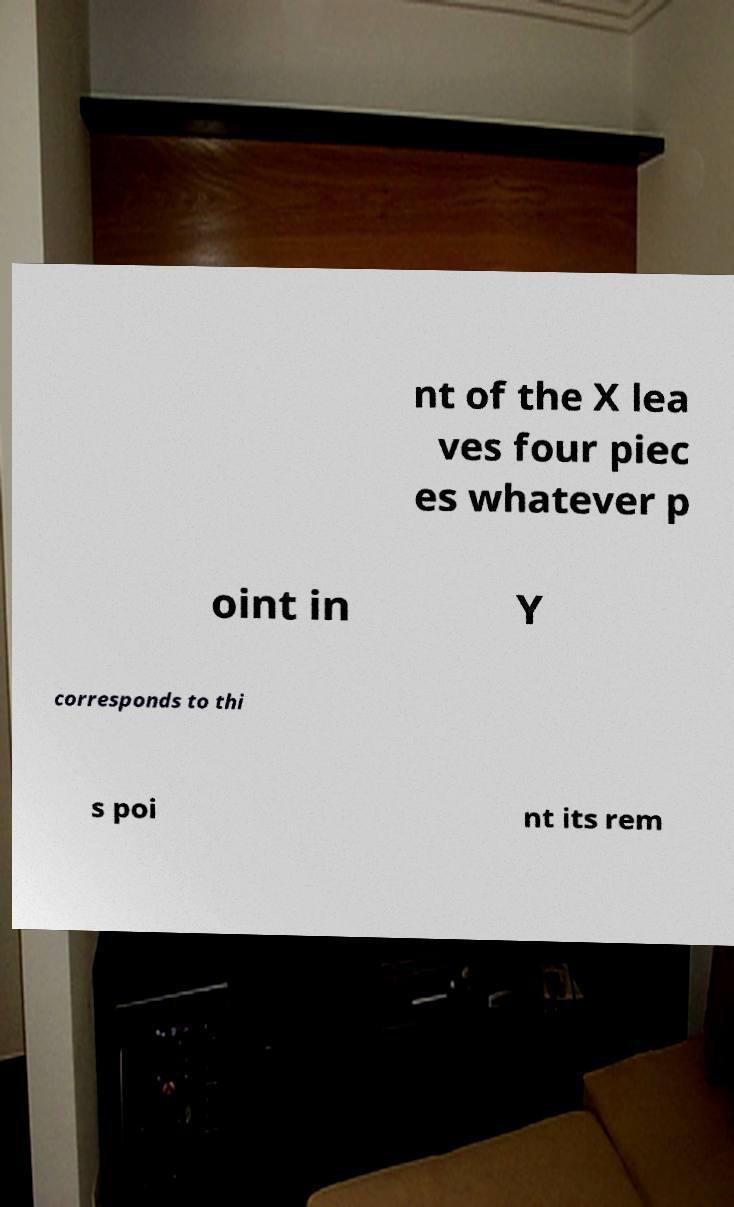Can you accurately transcribe the text from the provided image for me? nt of the X lea ves four piec es whatever p oint in Y corresponds to thi s poi nt its rem 